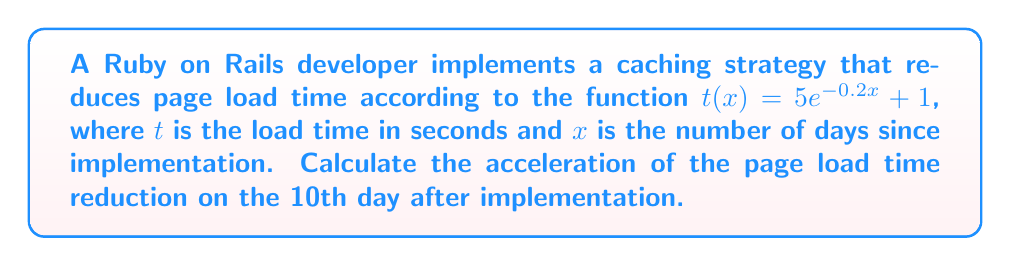Give your solution to this math problem. To solve this problem, we need to follow these steps:

1) The acceleration is the second derivative of the position function. In this case, our "position" function is the load time $t(x)$.

2) First, let's find the velocity (first derivative) of $t(x)$:

   $$\frac{dt}{dx} = -0.2 \cdot 5e^{-0.2x} = -e^{-0.2x}$$

3) Now, let's find the acceleration (second derivative) by differentiating the velocity:

   $$\frac{d^2t}{dx^2} = -(-0.2)e^{-0.2x} = 0.2e^{-0.2x}$$

4) We need to evaluate this at $x = 10$ (10 days after implementation):

   $$\frac{d^2t}{dx^2}(10) = 0.2e^{-0.2(10)} = 0.2e^{-2}$$

5) Calculate the final value:

   $$0.2e^{-2} \approx 0.0271 \text{ seconds/day}^2$$

This positive acceleration indicates that the rate of decrease in load time is slowing down over time.
Answer: $0.0271 \text{ seconds/day}^2$ 